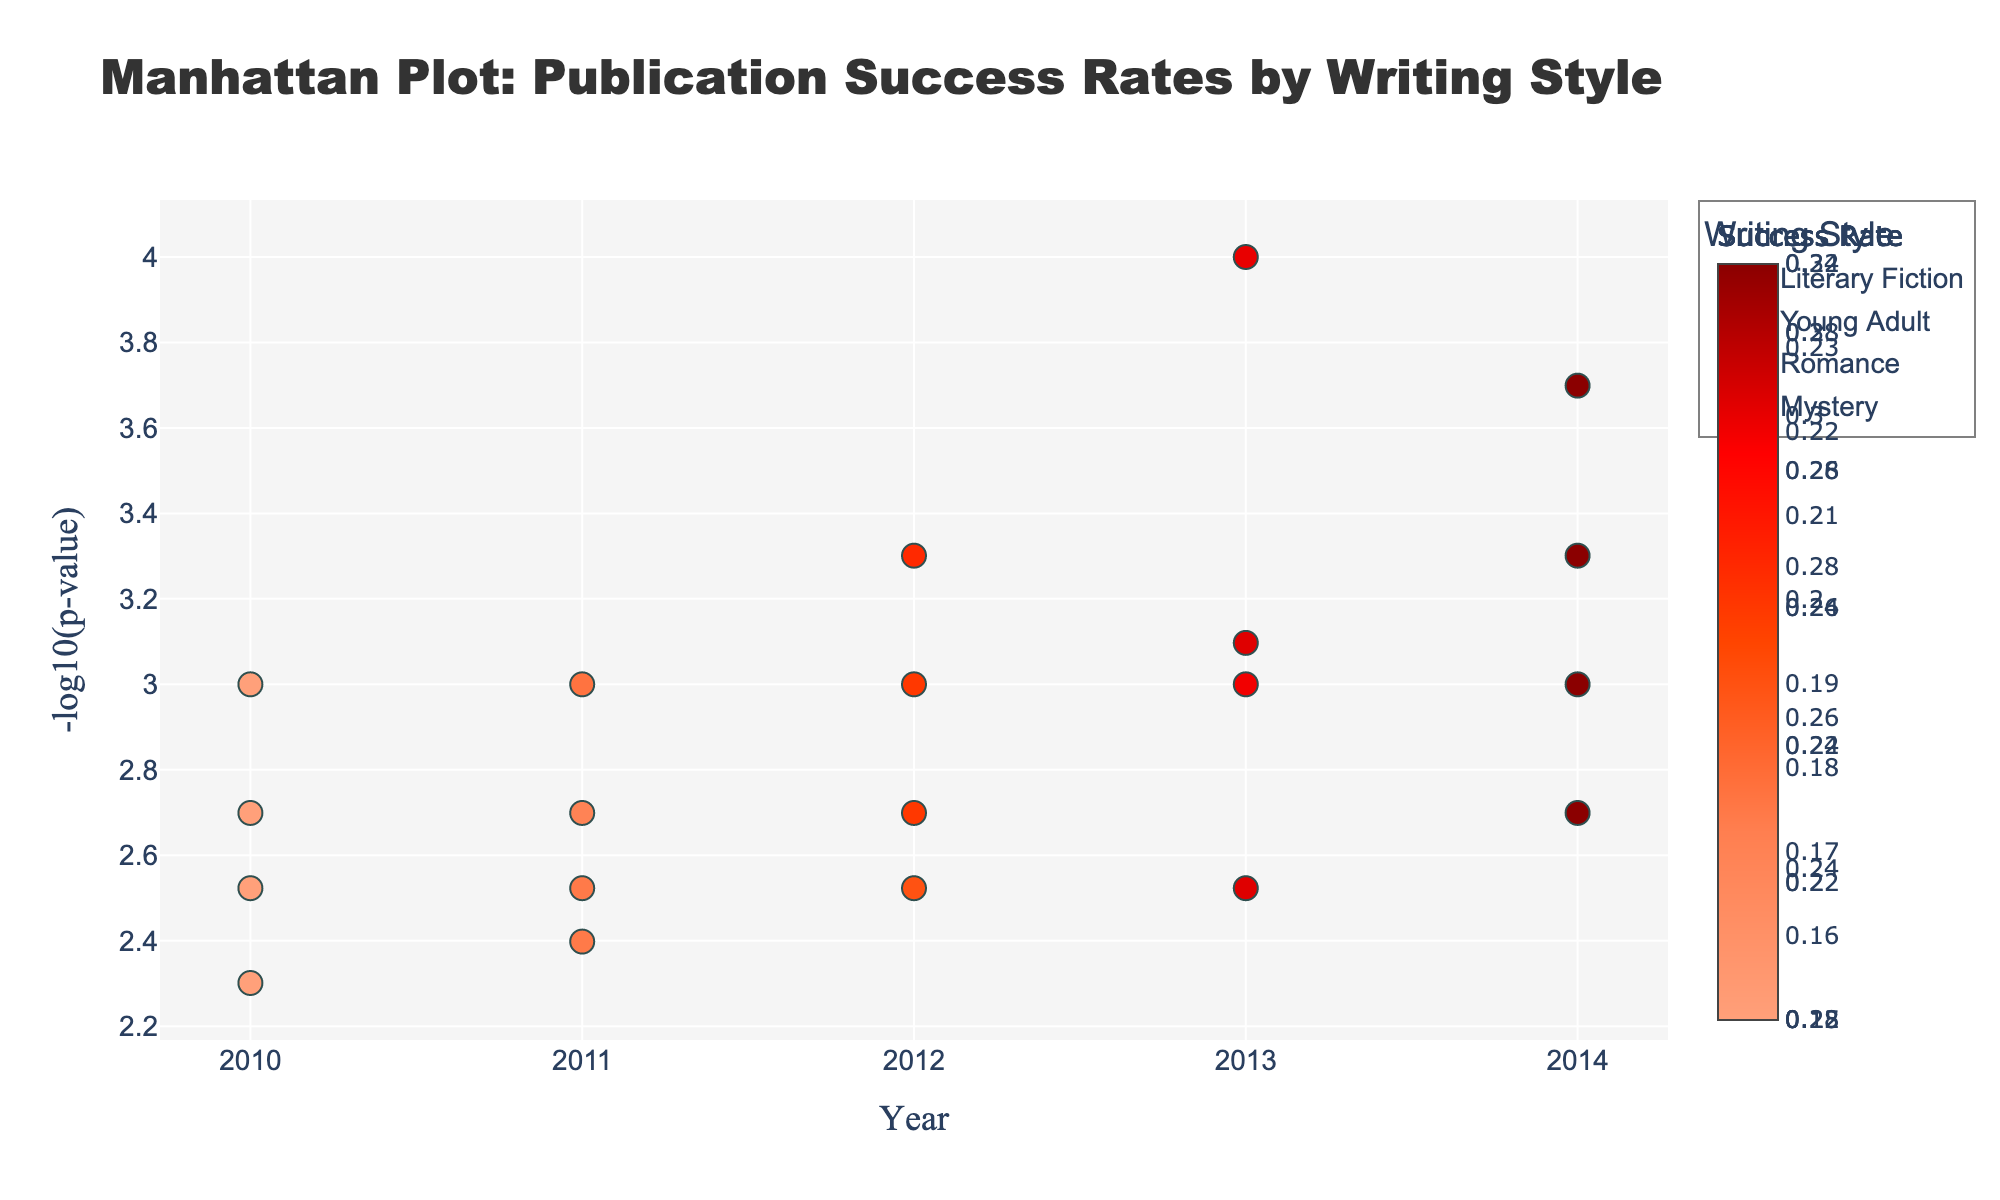What is the title of the figure? The title is usually located at the top of the figure. In this case, it's presented as "Manhattan Plot: Publication Success Rates by Writing Style."
Answer: Manhattan Plot: Publication Success Rates by Writing Style What years are included in the data? The x-axis lists the years examined, spanning from 2010 to 2014.
Answer: 2010 to 2014 How is the success rate visually represented? Each marker's color represents the success rate, with a color scale provided to interpret these values.
Answer: By marker color Which year shows the highest success rate for Young Adult writing style? By examining the markers for the Young Adult writing style, the year with the darkest marker (indicative of the highest success rate) is 2014.
Answer: 2014 What is the success rate for Literary Fiction in 2013? Hovering over the marker for Literary Fiction in 2013 reveals it has a success rate of 0.22.
Answer: 0.22 How do you interpret a higher -log10(p-value)? On a Manhattan Plot, a higher -log10(p-value) suggests stronger statistical significance.
Answer: Stronger statistical significance Which author had the highest success rate in 2012? The marker colors indicate success rates, and the darkest marker in 2012 belongs to Michael Chen for the Young Adult style.
Answer: Michael Chen How many data points are there for each writing style? Each year has a data point for every writing style. There are 5 years, so each style has 5 data points.
Answer: 5 data points per style Which writing style consistently shows the highest success rate over the years? By analyzing the color intensity on the markers across years, the Young Adult style consistently shows darker colors, indicating a higher success rate each year.
Answer: Young Adult Compare the -log10(p-value) for Romance and Mystery writing styles in 2014. Which one is higher? The y-axis shows -log10(p-value). The Romance style in 2014 appears lower at around 3, while Mystery is higher at around 3.3.
Answer: Mystery What does the marker size represent in this plot? The marker size does not change and thus does not represent any variable. Instead, color represents the success rate.
Answer: Not represented 